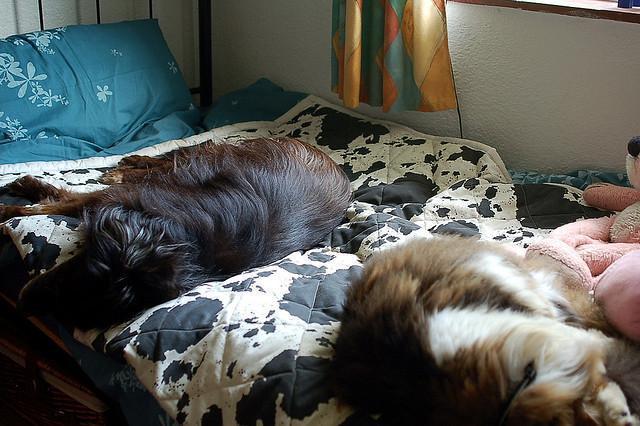How many dogs are in the photo?
Give a very brief answer. 2. How many people are in the image?
Give a very brief answer. 0. 